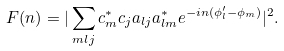<formula> <loc_0><loc_0><loc_500><loc_500>F ( n ) = | \sum _ { m l j } c _ { m } ^ { * } c _ { j } a _ { l j } a _ { l m } ^ { * } e ^ { - i n ( \phi _ { l } ^ { \prime } - \phi _ { m } ) } | ^ { 2 } .</formula> 